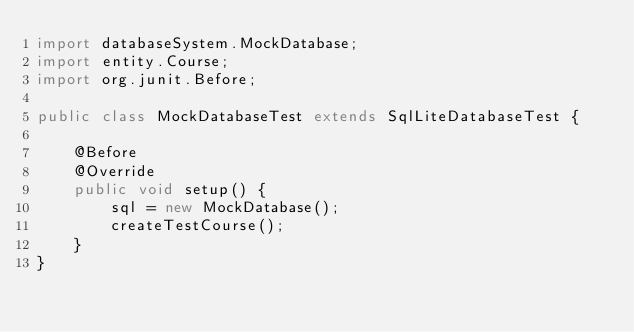Convert code to text. <code><loc_0><loc_0><loc_500><loc_500><_Java_>import databaseSystem.MockDatabase;
import entity.Course;
import org.junit.Before;

public class MockDatabaseTest extends SqlLiteDatabaseTest {

    @Before
    @Override
    public void setup() {
        sql = new MockDatabase();
        createTestCourse();
    }
}
</code> 